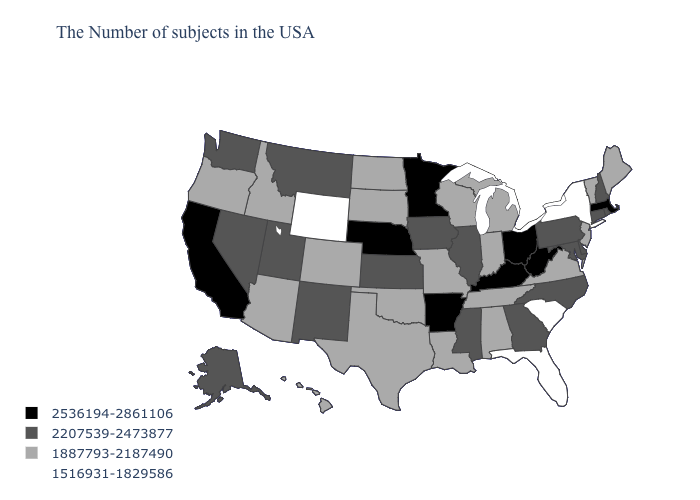What is the value of Nebraska?
Answer briefly. 2536194-2861106. Which states hav the highest value in the MidWest?
Write a very short answer. Ohio, Minnesota, Nebraska. Name the states that have a value in the range 2207539-2473877?
Quick response, please. Rhode Island, New Hampshire, Connecticut, Delaware, Maryland, Pennsylvania, North Carolina, Georgia, Illinois, Mississippi, Iowa, Kansas, New Mexico, Utah, Montana, Nevada, Washington, Alaska. Which states have the lowest value in the MidWest?
Be succinct. Michigan, Indiana, Wisconsin, Missouri, South Dakota, North Dakota. Does the first symbol in the legend represent the smallest category?
Short answer required. No. What is the value of Nebraska?
Write a very short answer. 2536194-2861106. Does Maine have the same value as Rhode Island?
Short answer required. No. Does the first symbol in the legend represent the smallest category?
Keep it brief. No. Does Pennsylvania have a higher value than Florida?
Write a very short answer. Yes. What is the value of Kansas?
Write a very short answer. 2207539-2473877. Does Alabama have the same value as South Dakota?
Be succinct. Yes. Which states have the highest value in the USA?
Answer briefly. Massachusetts, West Virginia, Ohio, Kentucky, Arkansas, Minnesota, Nebraska, California. Name the states that have a value in the range 1516931-1829586?
Concise answer only. New York, South Carolina, Florida, Wyoming. What is the value of North Dakota?
Write a very short answer. 1887793-2187490. Name the states that have a value in the range 1516931-1829586?
Write a very short answer. New York, South Carolina, Florida, Wyoming. 